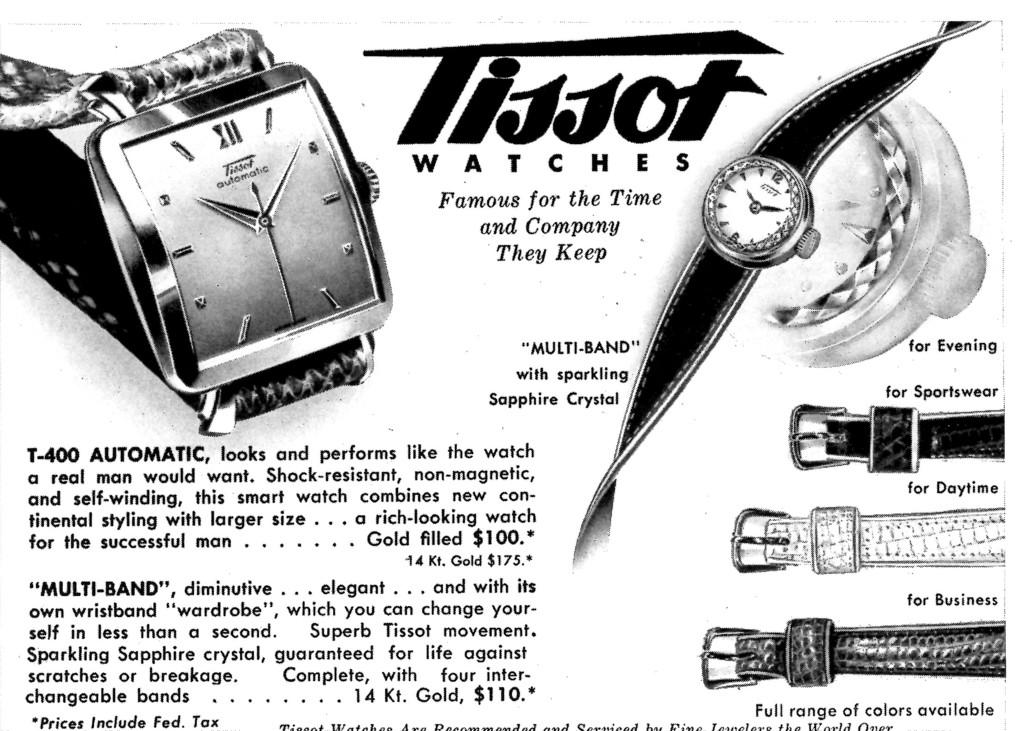What brand are the watches?
Your answer should be very brief. Tissot. What are the watches famous for?
Ensure brevity in your answer.  The time and company they keep. 